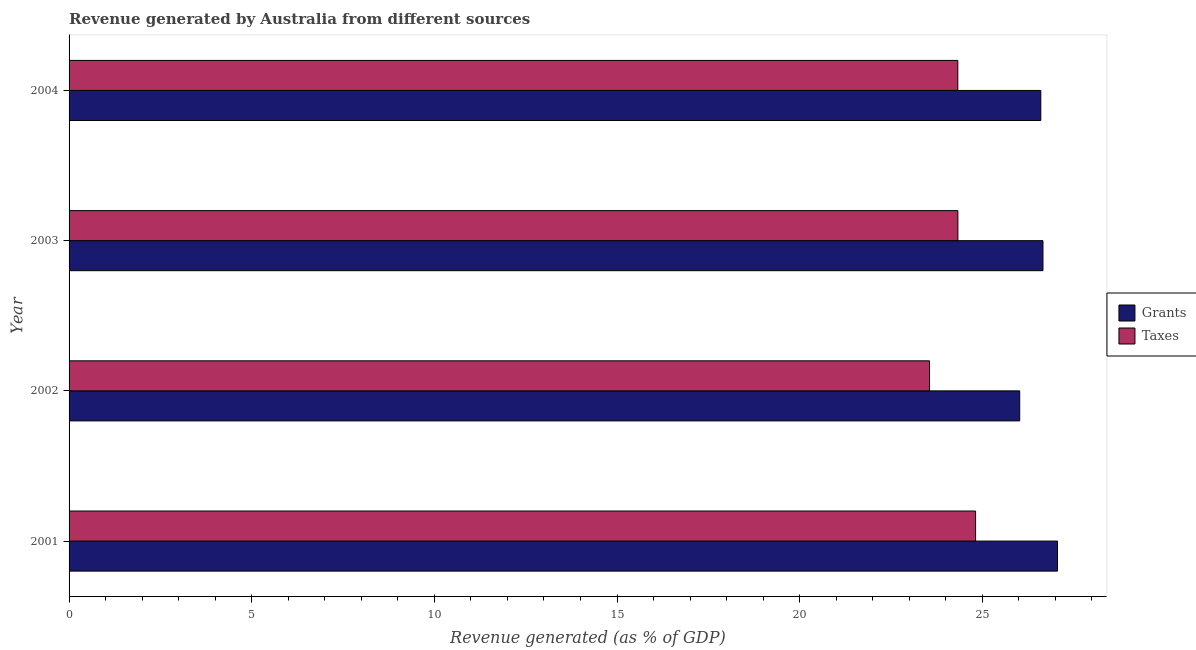How many groups of bars are there?
Your answer should be compact. 4. Are the number of bars per tick equal to the number of legend labels?
Provide a succinct answer. Yes. Are the number of bars on each tick of the Y-axis equal?
Keep it short and to the point. Yes. How many bars are there on the 1st tick from the top?
Provide a short and direct response. 2. How many bars are there on the 4th tick from the bottom?
Keep it short and to the point. 2. In how many cases, is the number of bars for a given year not equal to the number of legend labels?
Offer a very short reply. 0. What is the revenue generated by taxes in 2002?
Your response must be concise. 23.56. Across all years, what is the maximum revenue generated by grants?
Ensure brevity in your answer.  27.06. Across all years, what is the minimum revenue generated by grants?
Your answer should be compact. 26.02. In which year was the revenue generated by grants maximum?
Provide a short and direct response. 2001. What is the total revenue generated by taxes in the graph?
Provide a short and direct response. 97.03. What is the difference between the revenue generated by grants in 2001 and that in 2003?
Ensure brevity in your answer.  0.4. What is the difference between the revenue generated by taxes in 2002 and the revenue generated by grants in 2004?
Your response must be concise. -3.05. What is the average revenue generated by taxes per year?
Your response must be concise. 24.26. In the year 2002, what is the difference between the revenue generated by grants and revenue generated by taxes?
Give a very brief answer. 2.47. In how many years, is the revenue generated by grants greater than 21 %?
Your answer should be compact. 4. Is the difference between the revenue generated by grants in 2002 and 2003 greater than the difference between the revenue generated by taxes in 2002 and 2003?
Provide a succinct answer. Yes. What is the difference between the highest and the second highest revenue generated by taxes?
Provide a short and direct response. 0.48. What does the 2nd bar from the top in 2004 represents?
Provide a succinct answer. Grants. What does the 2nd bar from the bottom in 2002 represents?
Make the answer very short. Taxes. How many years are there in the graph?
Your answer should be compact. 4. What is the difference between two consecutive major ticks on the X-axis?
Your answer should be compact. 5. Does the graph contain grids?
Your response must be concise. No. Where does the legend appear in the graph?
Your response must be concise. Center right. How many legend labels are there?
Offer a very short reply. 2. What is the title of the graph?
Make the answer very short. Revenue generated by Australia from different sources. Does "Non-pregnant women" appear as one of the legend labels in the graph?
Make the answer very short. No. What is the label or title of the X-axis?
Ensure brevity in your answer.  Revenue generated (as % of GDP). What is the Revenue generated (as % of GDP) in Grants in 2001?
Ensure brevity in your answer.  27.06. What is the Revenue generated (as % of GDP) of Taxes in 2001?
Provide a succinct answer. 24.82. What is the Revenue generated (as % of GDP) in Grants in 2002?
Provide a short and direct response. 26.02. What is the Revenue generated (as % of GDP) in Taxes in 2002?
Provide a short and direct response. 23.56. What is the Revenue generated (as % of GDP) in Grants in 2003?
Your response must be concise. 26.66. What is the Revenue generated (as % of GDP) of Taxes in 2003?
Your response must be concise. 24.33. What is the Revenue generated (as % of GDP) in Grants in 2004?
Your answer should be very brief. 26.6. What is the Revenue generated (as % of GDP) in Taxes in 2004?
Offer a very short reply. 24.33. Across all years, what is the maximum Revenue generated (as % of GDP) of Grants?
Provide a short and direct response. 27.06. Across all years, what is the maximum Revenue generated (as % of GDP) of Taxes?
Give a very brief answer. 24.82. Across all years, what is the minimum Revenue generated (as % of GDP) of Grants?
Ensure brevity in your answer.  26.02. Across all years, what is the minimum Revenue generated (as % of GDP) in Taxes?
Provide a succinct answer. 23.56. What is the total Revenue generated (as % of GDP) of Grants in the graph?
Your answer should be very brief. 106.35. What is the total Revenue generated (as % of GDP) in Taxes in the graph?
Give a very brief answer. 97.03. What is the difference between the Revenue generated (as % of GDP) in Grants in 2001 and that in 2002?
Ensure brevity in your answer.  1.03. What is the difference between the Revenue generated (as % of GDP) in Taxes in 2001 and that in 2002?
Your answer should be very brief. 1.26. What is the difference between the Revenue generated (as % of GDP) in Grants in 2001 and that in 2003?
Offer a very short reply. 0.4. What is the difference between the Revenue generated (as % of GDP) in Taxes in 2001 and that in 2003?
Your response must be concise. 0.49. What is the difference between the Revenue generated (as % of GDP) in Grants in 2001 and that in 2004?
Your answer should be compact. 0.46. What is the difference between the Revenue generated (as % of GDP) in Taxes in 2001 and that in 2004?
Give a very brief answer. 0.49. What is the difference between the Revenue generated (as % of GDP) of Grants in 2002 and that in 2003?
Offer a very short reply. -0.64. What is the difference between the Revenue generated (as % of GDP) of Taxes in 2002 and that in 2003?
Provide a succinct answer. -0.78. What is the difference between the Revenue generated (as % of GDP) in Grants in 2002 and that in 2004?
Provide a succinct answer. -0.58. What is the difference between the Revenue generated (as % of GDP) in Taxes in 2002 and that in 2004?
Provide a succinct answer. -0.77. What is the difference between the Revenue generated (as % of GDP) of Grants in 2003 and that in 2004?
Provide a short and direct response. 0.06. What is the difference between the Revenue generated (as % of GDP) of Taxes in 2003 and that in 2004?
Ensure brevity in your answer.  0. What is the difference between the Revenue generated (as % of GDP) of Grants in 2001 and the Revenue generated (as % of GDP) of Taxes in 2002?
Provide a short and direct response. 3.5. What is the difference between the Revenue generated (as % of GDP) of Grants in 2001 and the Revenue generated (as % of GDP) of Taxes in 2003?
Your response must be concise. 2.73. What is the difference between the Revenue generated (as % of GDP) of Grants in 2001 and the Revenue generated (as % of GDP) of Taxes in 2004?
Provide a succinct answer. 2.73. What is the difference between the Revenue generated (as % of GDP) in Grants in 2002 and the Revenue generated (as % of GDP) in Taxes in 2003?
Provide a short and direct response. 1.69. What is the difference between the Revenue generated (as % of GDP) in Grants in 2002 and the Revenue generated (as % of GDP) in Taxes in 2004?
Your answer should be compact. 1.69. What is the difference between the Revenue generated (as % of GDP) of Grants in 2003 and the Revenue generated (as % of GDP) of Taxes in 2004?
Your answer should be very brief. 2.33. What is the average Revenue generated (as % of GDP) in Grants per year?
Keep it short and to the point. 26.59. What is the average Revenue generated (as % of GDP) of Taxes per year?
Ensure brevity in your answer.  24.26. In the year 2001, what is the difference between the Revenue generated (as % of GDP) of Grants and Revenue generated (as % of GDP) of Taxes?
Provide a succinct answer. 2.24. In the year 2002, what is the difference between the Revenue generated (as % of GDP) in Grants and Revenue generated (as % of GDP) in Taxes?
Make the answer very short. 2.47. In the year 2003, what is the difference between the Revenue generated (as % of GDP) in Grants and Revenue generated (as % of GDP) in Taxes?
Your answer should be very brief. 2.33. In the year 2004, what is the difference between the Revenue generated (as % of GDP) in Grants and Revenue generated (as % of GDP) in Taxes?
Offer a very short reply. 2.27. What is the ratio of the Revenue generated (as % of GDP) of Grants in 2001 to that in 2002?
Provide a short and direct response. 1.04. What is the ratio of the Revenue generated (as % of GDP) of Taxes in 2001 to that in 2002?
Your answer should be compact. 1.05. What is the ratio of the Revenue generated (as % of GDP) in Grants in 2001 to that in 2003?
Your answer should be compact. 1.01. What is the ratio of the Revenue generated (as % of GDP) of Taxes in 2001 to that in 2003?
Give a very brief answer. 1.02. What is the ratio of the Revenue generated (as % of GDP) in Grants in 2001 to that in 2004?
Offer a terse response. 1.02. What is the ratio of the Revenue generated (as % of GDP) of Grants in 2002 to that in 2003?
Keep it short and to the point. 0.98. What is the ratio of the Revenue generated (as % of GDP) of Taxes in 2002 to that in 2003?
Your answer should be compact. 0.97. What is the ratio of the Revenue generated (as % of GDP) in Grants in 2002 to that in 2004?
Offer a terse response. 0.98. What is the ratio of the Revenue generated (as % of GDP) in Taxes in 2002 to that in 2004?
Provide a succinct answer. 0.97. What is the ratio of the Revenue generated (as % of GDP) of Grants in 2003 to that in 2004?
Offer a terse response. 1. What is the ratio of the Revenue generated (as % of GDP) in Taxes in 2003 to that in 2004?
Ensure brevity in your answer.  1. What is the difference between the highest and the second highest Revenue generated (as % of GDP) of Grants?
Provide a short and direct response. 0.4. What is the difference between the highest and the second highest Revenue generated (as % of GDP) of Taxes?
Provide a short and direct response. 0.49. What is the difference between the highest and the lowest Revenue generated (as % of GDP) of Grants?
Make the answer very short. 1.03. What is the difference between the highest and the lowest Revenue generated (as % of GDP) of Taxes?
Make the answer very short. 1.26. 